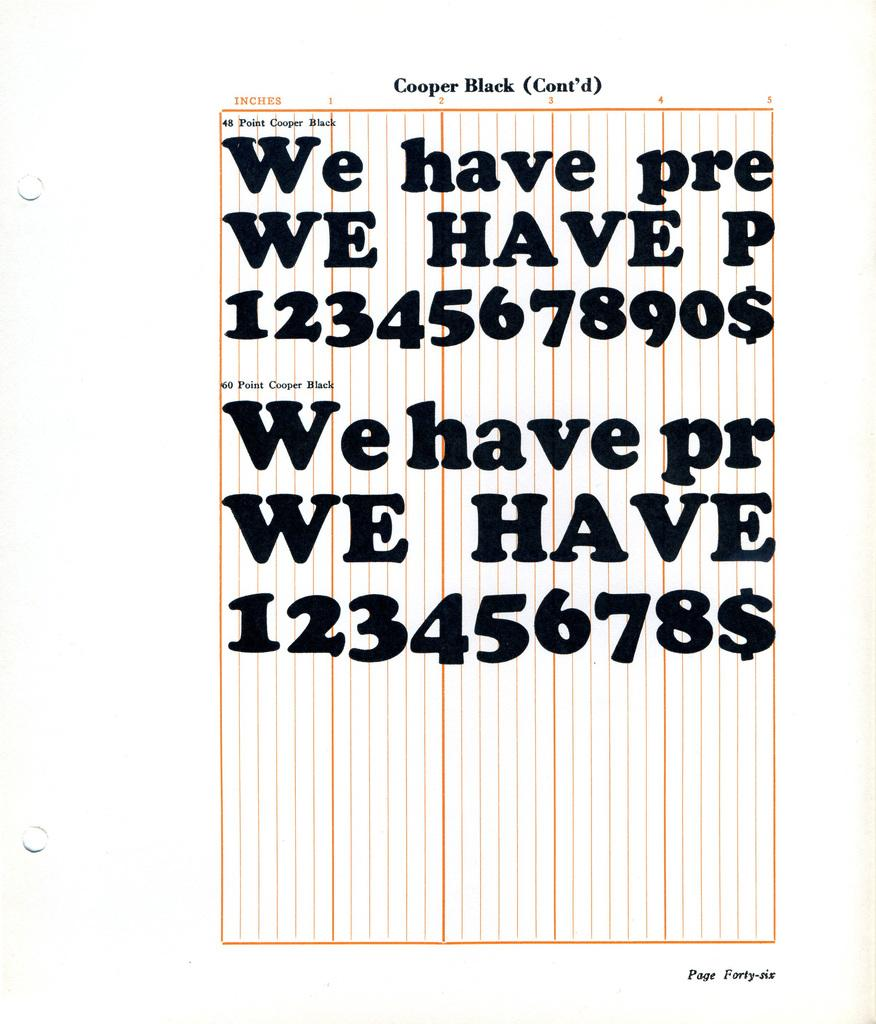<image>
Write a terse but informative summary of the picture. a list that has the letters pr on it 